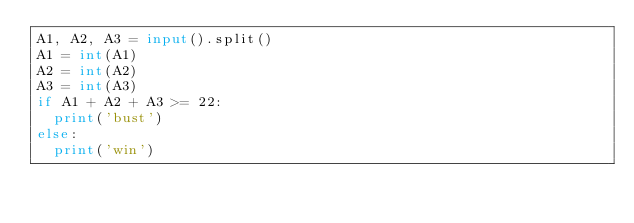Convert code to text. <code><loc_0><loc_0><loc_500><loc_500><_Python_>A1, A2, A3 = input().split()
A1 = int(A1)
A2 = int(A2)
A3 = int(A3)
if A1 + A2 + A3 >= 22:
  print('bust')
else:
  print('win')</code> 